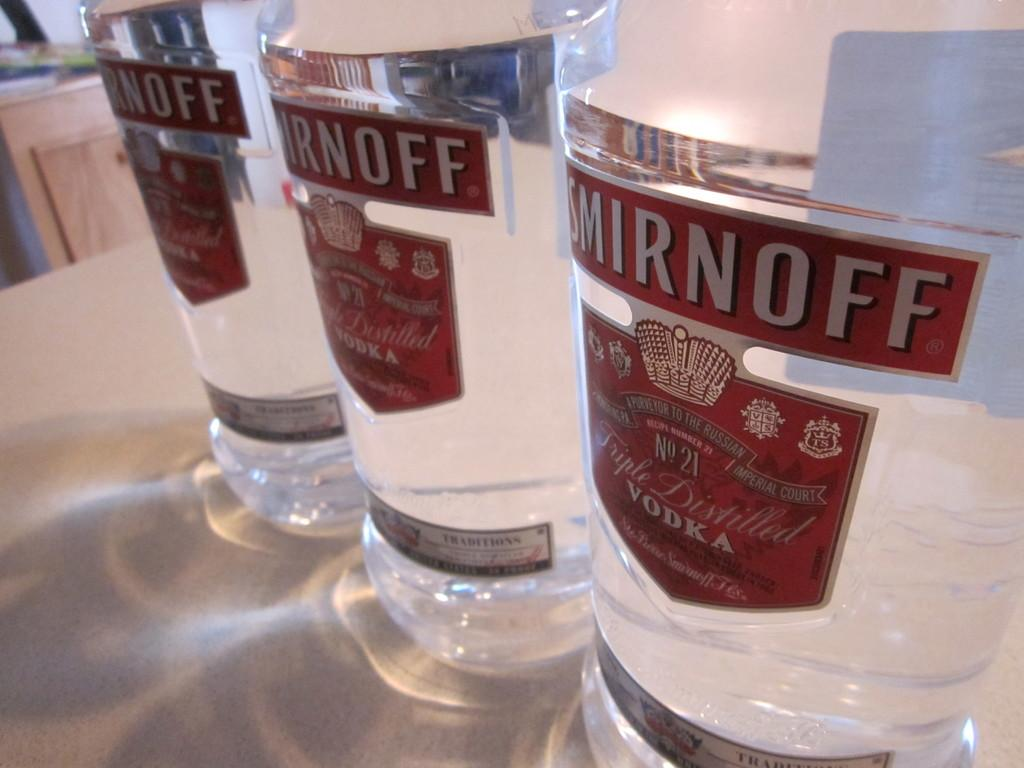<image>
Render a clear and concise summary of the photo. Three bottles of Smirnoff lined up next to each other. 